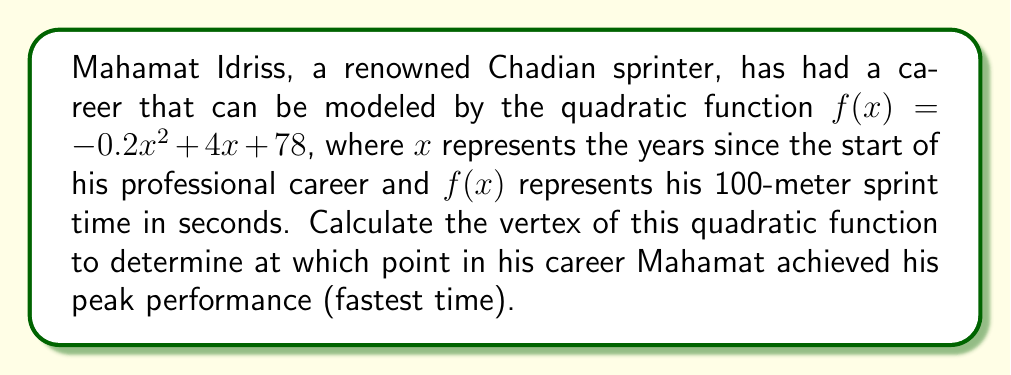Help me with this question. To find the vertex of a quadratic function in the form $f(x) = ax^2 + bx + c$, we can use the formula:

$x = -\frac{b}{2a}$

Where $a$ and $b$ are the coefficients of $x^2$ and $x$ respectively.

For Mahamat's career function: $f(x) = -0.2x^2 + 4x + 78$

1) Identify $a$ and $b$:
   $a = -0.2$
   $b = 4$

2) Apply the formula:
   $x = -\frac{b}{2a} = -\frac{4}{2(-0.2)} = -\frac{4}{-0.4} = 10$

3) To find the y-coordinate of the vertex, substitute $x = 10$ into the original function:

   $f(10) = -0.2(10)^2 + 4(10) + 78$
   $= -0.2(100) + 40 + 78$
   $= -20 + 40 + 78$
   $= 98$

Therefore, the vertex of the quadratic function is (10, 98).
Answer: (10, 98) 